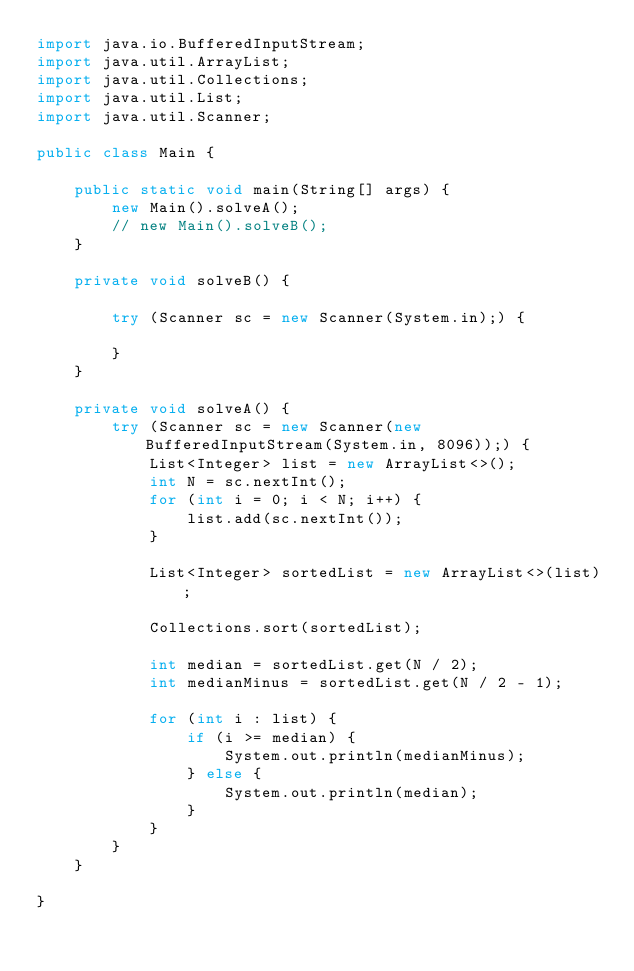<code> <loc_0><loc_0><loc_500><loc_500><_Java_>import java.io.BufferedInputStream;
import java.util.ArrayList;
import java.util.Collections;
import java.util.List;
import java.util.Scanner;

public class Main {

    public static void main(String[] args) {
        new Main().solveA();
        // new Main().solveB();
    }

    private void solveB() {

        try (Scanner sc = new Scanner(System.in);) {

        }
    }

    private void solveA() {
        try (Scanner sc = new Scanner(new BufferedInputStream(System.in, 8096));) {
            List<Integer> list = new ArrayList<>();
            int N = sc.nextInt();
            for (int i = 0; i < N; i++) {
                list.add(sc.nextInt());
            }

            List<Integer> sortedList = new ArrayList<>(list);

            Collections.sort(sortedList);

            int median = sortedList.get(N / 2);
            int medianMinus = sortedList.get(N / 2 - 1);

            for (int i : list) {
                if (i >= median) {
                    System.out.println(medianMinus);
                } else {
                    System.out.println(median);
                }
            }
        }
    }

}
</code> 